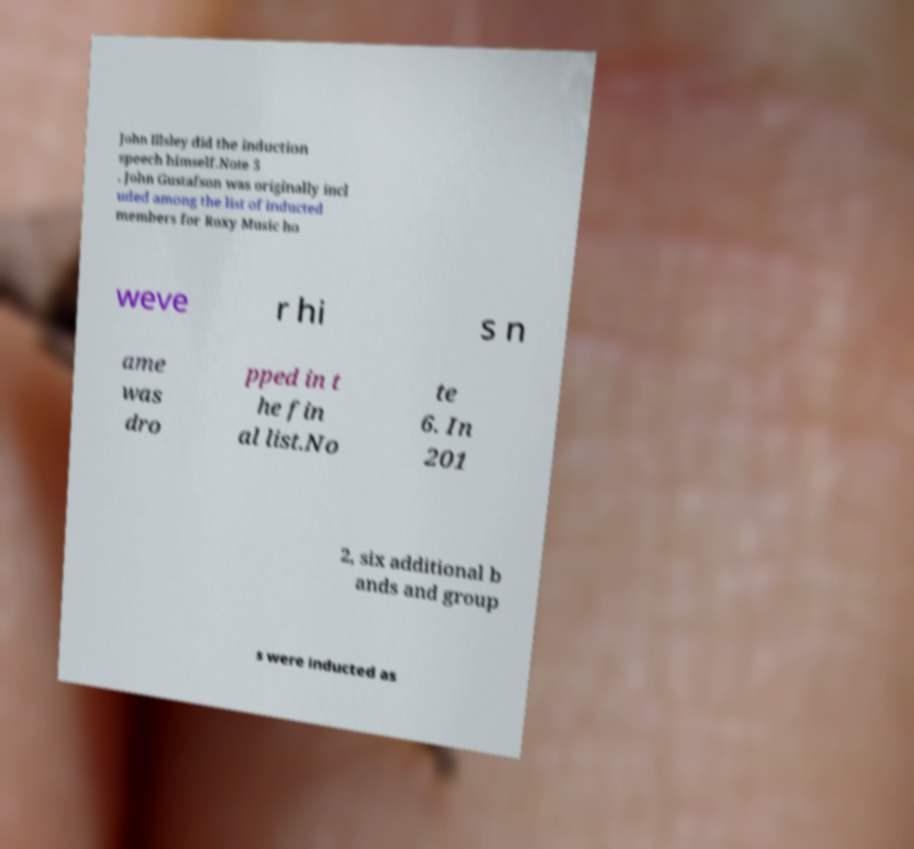Could you extract and type out the text from this image? John Illsley did the induction speech himself.Note 5 . John Gustafson was originally incl uded among the list of inducted members for Roxy Music ho weve r hi s n ame was dro pped in t he fin al list.No te 6. In 201 2, six additional b ands and group s were inducted as 